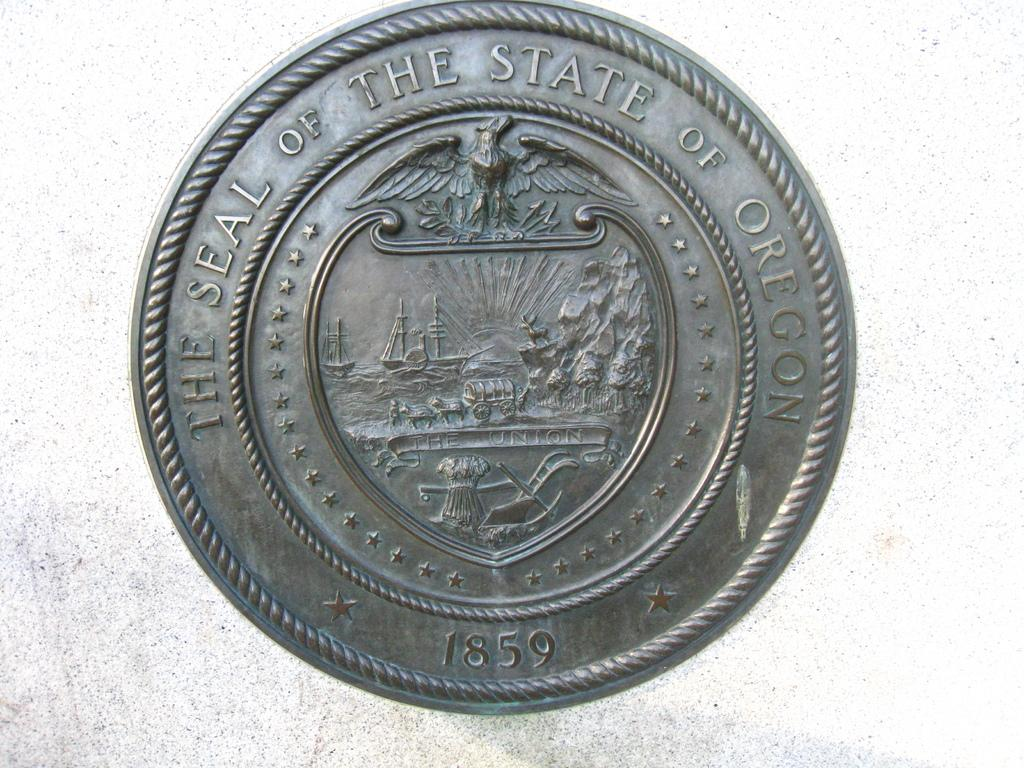<image>
Offer a succinct explanation of the picture presented. The Oregon state seal has sailboats and schooners in the center of it. 